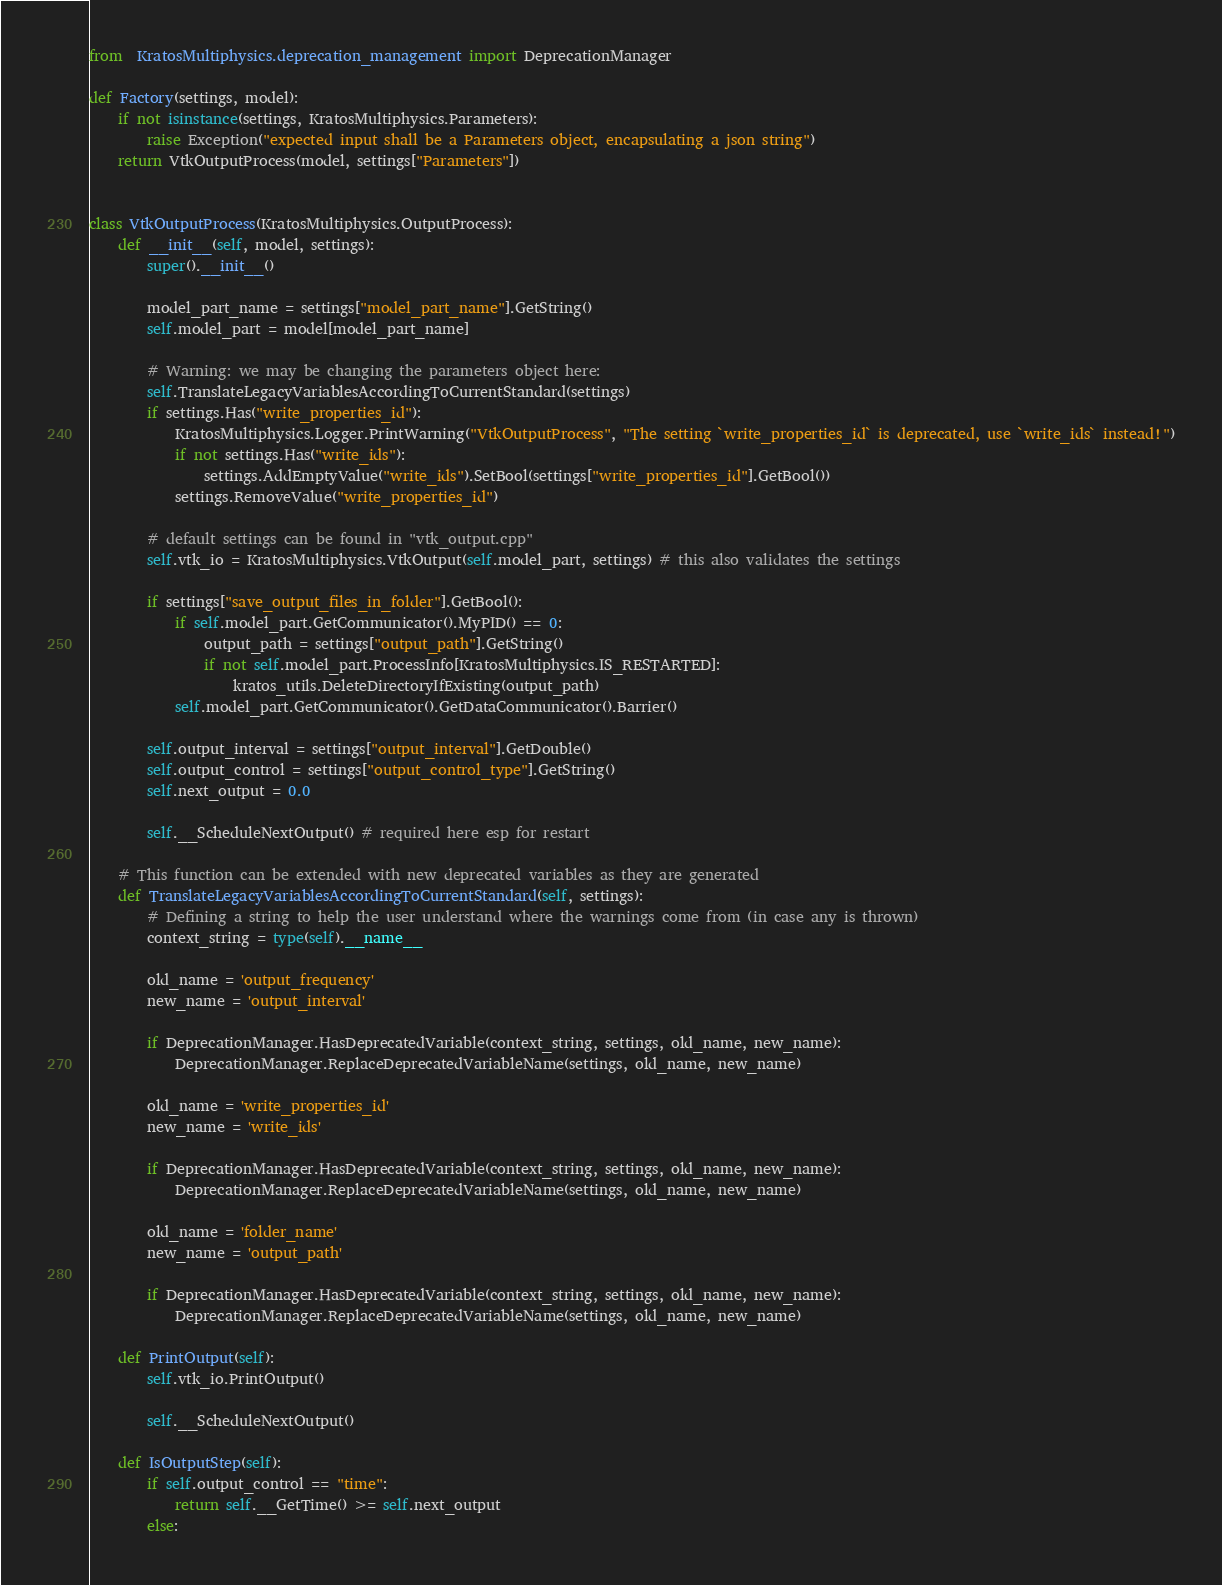Convert code to text. <code><loc_0><loc_0><loc_500><loc_500><_Python_>from  KratosMultiphysics.deprecation_management import DeprecationManager

def Factory(settings, model):
    if not isinstance(settings, KratosMultiphysics.Parameters):
        raise Exception("expected input shall be a Parameters object, encapsulating a json string")
    return VtkOutputProcess(model, settings["Parameters"])


class VtkOutputProcess(KratosMultiphysics.OutputProcess):
    def __init__(self, model, settings):
        super().__init__()

        model_part_name = settings["model_part_name"].GetString()
        self.model_part = model[model_part_name]

        # Warning: we may be changing the parameters object here:
        self.TranslateLegacyVariablesAccordingToCurrentStandard(settings)
        if settings.Has("write_properties_id"):
            KratosMultiphysics.Logger.PrintWarning("VtkOutputProcess", "The setting `write_properties_id` is deprecated, use `write_ids` instead!")
            if not settings.Has("write_ids"):
                settings.AddEmptyValue("write_ids").SetBool(settings["write_properties_id"].GetBool())
            settings.RemoveValue("write_properties_id")

        # default settings can be found in "vtk_output.cpp"
        self.vtk_io = KratosMultiphysics.VtkOutput(self.model_part, settings) # this also validates the settings

        if settings["save_output_files_in_folder"].GetBool():
            if self.model_part.GetCommunicator().MyPID() == 0:
                output_path = settings["output_path"].GetString()
                if not self.model_part.ProcessInfo[KratosMultiphysics.IS_RESTARTED]:
                    kratos_utils.DeleteDirectoryIfExisting(output_path)
            self.model_part.GetCommunicator().GetDataCommunicator().Barrier()

        self.output_interval = settings["output_interval"].GetDouble()
        self.output_control = settings["output_control_type"].GetString()
        self.next_output = 0.0

        self.__ScheduleNextOutput() # required here esp for restart

    # This function can be extended with new deprecated variables as they are generated
    def TranslateLegacyVariablesAccordingToCurrentStandard(self, settings):
        # Defining a string to help the user understand where the warnings come from (in case any is thrown)
        context_string = type(self).__name__

        old_name = 'output_frequency'
        new_name = 'output_interval'

        if DeprecationManager.HasDeprecatedVariable(context_string, settings, old_name, new_name):
            DeprecationManager.ReplaceDeprecatedVariableName(settings, old_name, new_name)

        old_name = 'write_properties_id'
        new_name = 'write_ids'

        if DeprecationManager.HasDeprecatedVariable(context_string, settings, old_name, new_name):
            DeprecationManager.ReplaceDeprecatedVariableName(settings, old_name, new_name)

        old_name = 'folder_name'
        new_name = 'output_path'

        if DeprecationManager.HasDeprecatedVariable(context_string, settings, old_name, new_name):
            DeprecationManager.ReplaceDeprecatedVariableName(settings, old_name, new_name)

    def PrintOutput(self):
        self.vtk_io.PrintOutput()

        self.__ScheduleNextOutput()

    def IsOutputStep(self):
        if self.output_control == "time":
            return self.__GetTime() >= self.next_output
        else:</code> 